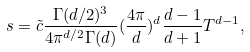Convert formula to latex. <formula><loc_0><loc_0><loc_500><loc_500>s = \tilde { c } \frac { \Gamma ( d / 2 ) ^ { 3 } } { 4 \pi ^ { d / 2 } \Gamma ( d ) } ( \frac { 4 \pi } { d } ) ^ { d } \frac { d - 1 } { d + 1 } T ^ { d - 1 } ,</formula> 